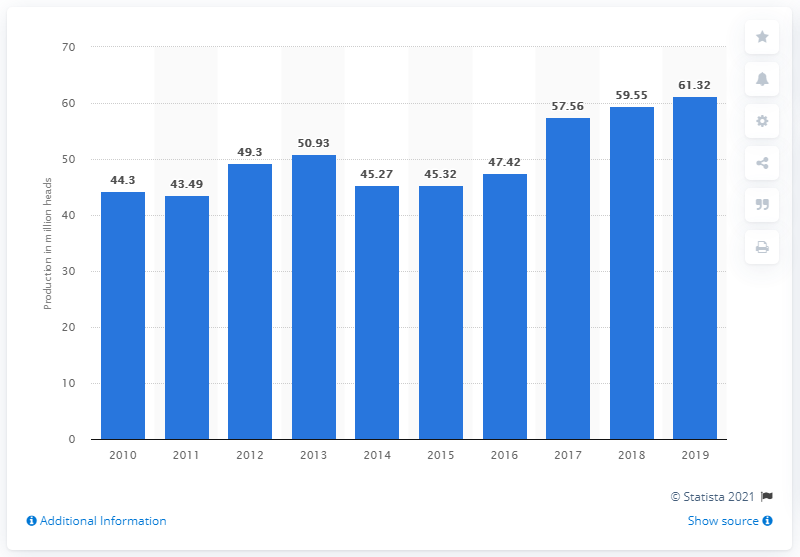Outline some significant characteristics in this image. In 2019, a total of 61,320 ducks were produced in Indonesia. 